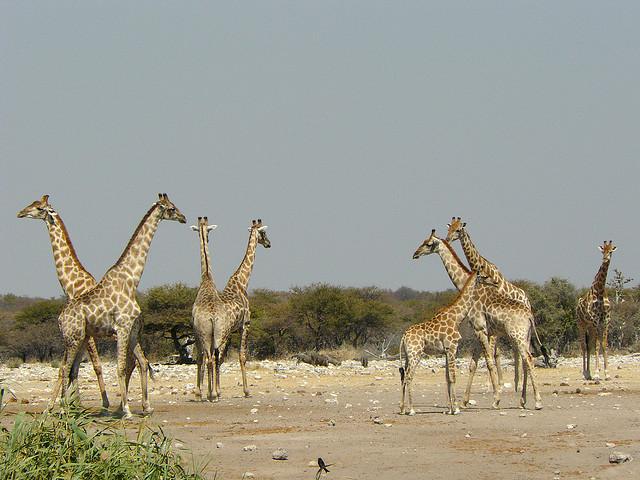Where is the grass?
Write a very short answer. On ground. Is there a bird in this picture?
Answer briefly. Yes. How many giraffes are in the wild?
Give a very brief answer. 8. 